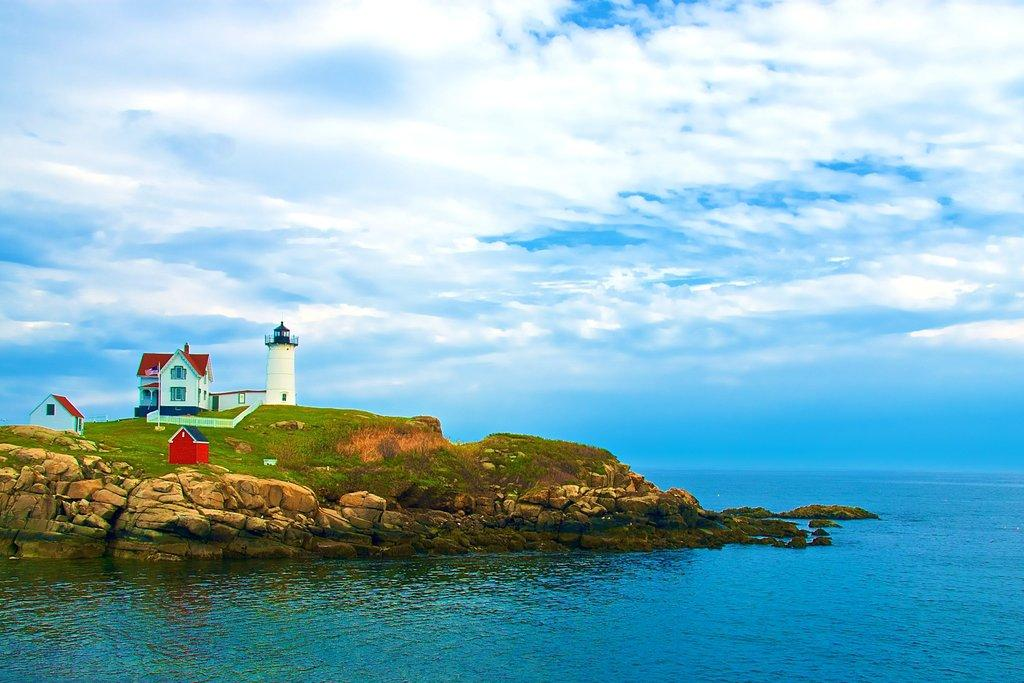What type of structures can be seen in the image? There are houses and a lighthouse in the image. What is the landscape like in the image? There is grass on a hill and water at the bottom of the image. What can be seen in the background of the image? The sky is visible in the background of the image. What book is being read by the lighthouse in the image? There is no book present in the image, and lighthouses do not read books. 